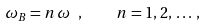<formula> <loc_0><loc_0><loc_500><loc_500>\omega _ { B } = n \, \omega \ , \quad n = 1 , \, 2 , \, \dots \, ,</formula> 